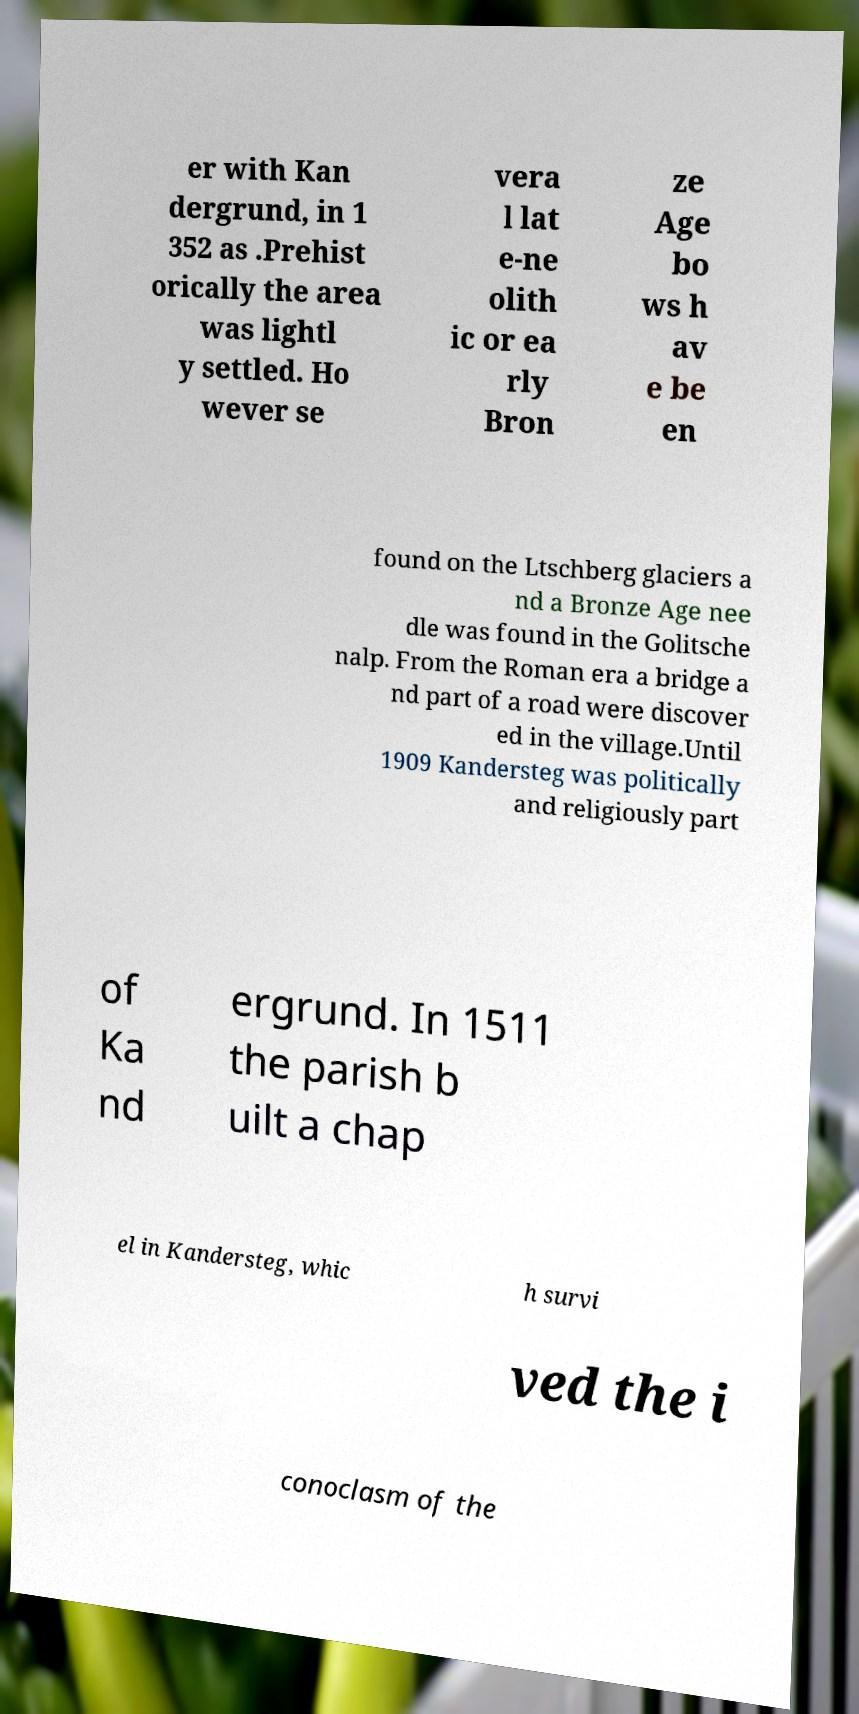Can you read and provide the text displayed in the image?This photo seems to have some interesting text. Can you extract and type it out for me? er with Kan dergrund, in 1 352 as .Prehist orically the area was lightl y settled. Ho wever se vera l lat e-ne olith ic or ea rly Bron ze Age bo ws h av e be en found on the Ltschberg glaciers a nd a Bronze Age nee dle was found in the Golitsche nalp. From the Roman era a bridge a nd part of a road were discover ed in the village.Until 1909 Kandersteg was politically and religiously part of Ka nd ergrund. In 1511 the parish b uilt a chap el in Kandersteg, whic h survi ved the i conoclasm of the 